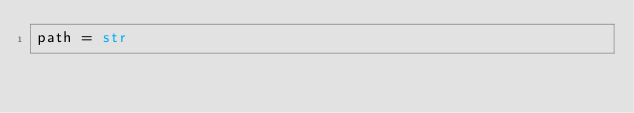Convert code to text. <code><loc_0><loc_0><loc_500><loc_500><_Python_>path = str</code> 